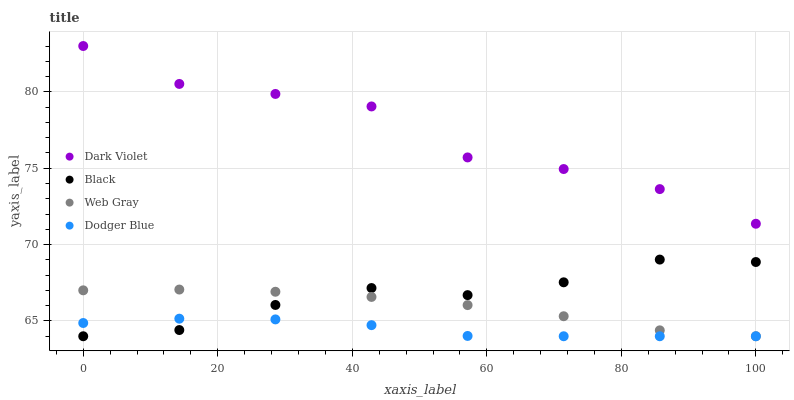Does Dodger Blue have the minimum area under the curve?
Answer yes or no. Yes. Does Dark Violet have the maximum area under the curve?
Answer yes or no. Yes. Does Web Gray have the minimum area under the curve?
Answer yes or no. No. Does Web Gray have the maximum area under the curve?
Answer yes or no. No. Is Web Gray the smoothest?
Answer yes or no. Yes. Is Dark Violet the roughest?
Answer yes or no. Yes. Is Black the smoothest?
Answer yes or no. No. Is Black the roughest?
Answer yes or no. No. Does Dodger Blue have the lowest value?
Answer yes or no. Yes. Does Dark Violet have the lowest value?
Answer yes or no. No. Does Dark Violet have the highest value?
Answer yes or no. Yes. Does Web Gray have the highest value?
Answer yes or no. No. Is Web Gray less than Dark Violet?
Answer yes or no. Yes. Is Dark Violet greater than Dodger Blue?
Answer yes or no. Yes. Does Dodger Blue intersect Black?
Answer yes or no. Yes. Is Dodger Blue less than Black?
Answer yes or no. No. Is Dodger Blue greater than Black?
Answer yes or no. No. Does Web Gray intersect Dark Violet?
Answer yes or no. No. 